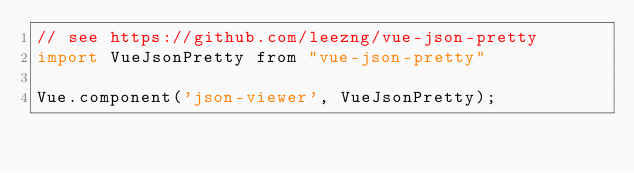<code> <loc_0><loc_0><loc_500><loc_500><_JavaScript_>// see https://github.com/leezng/vue-json-pretty
import VueJsonPretty from "vue-json-pretty"

Vue.component('json-viewer', VueJsonPretty);</code> 